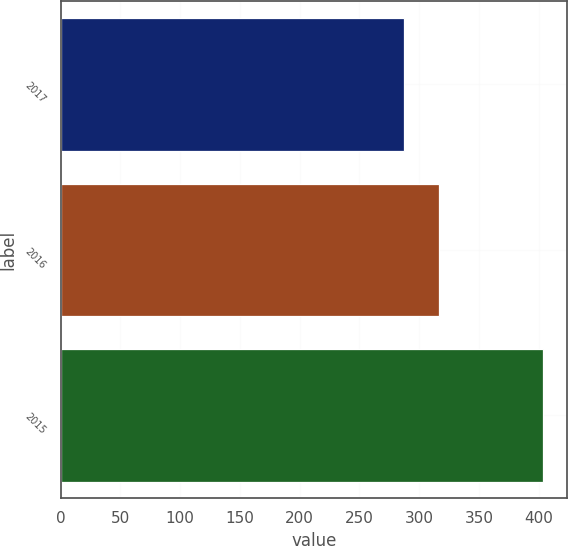<chart> <loc_0><loc_0><loc_500><loc_500><bar_chart><fcel>2017<fcel>2016<fcel>2015<nl><fcel>287<fcel>317<fcel>404<nl></chart> 